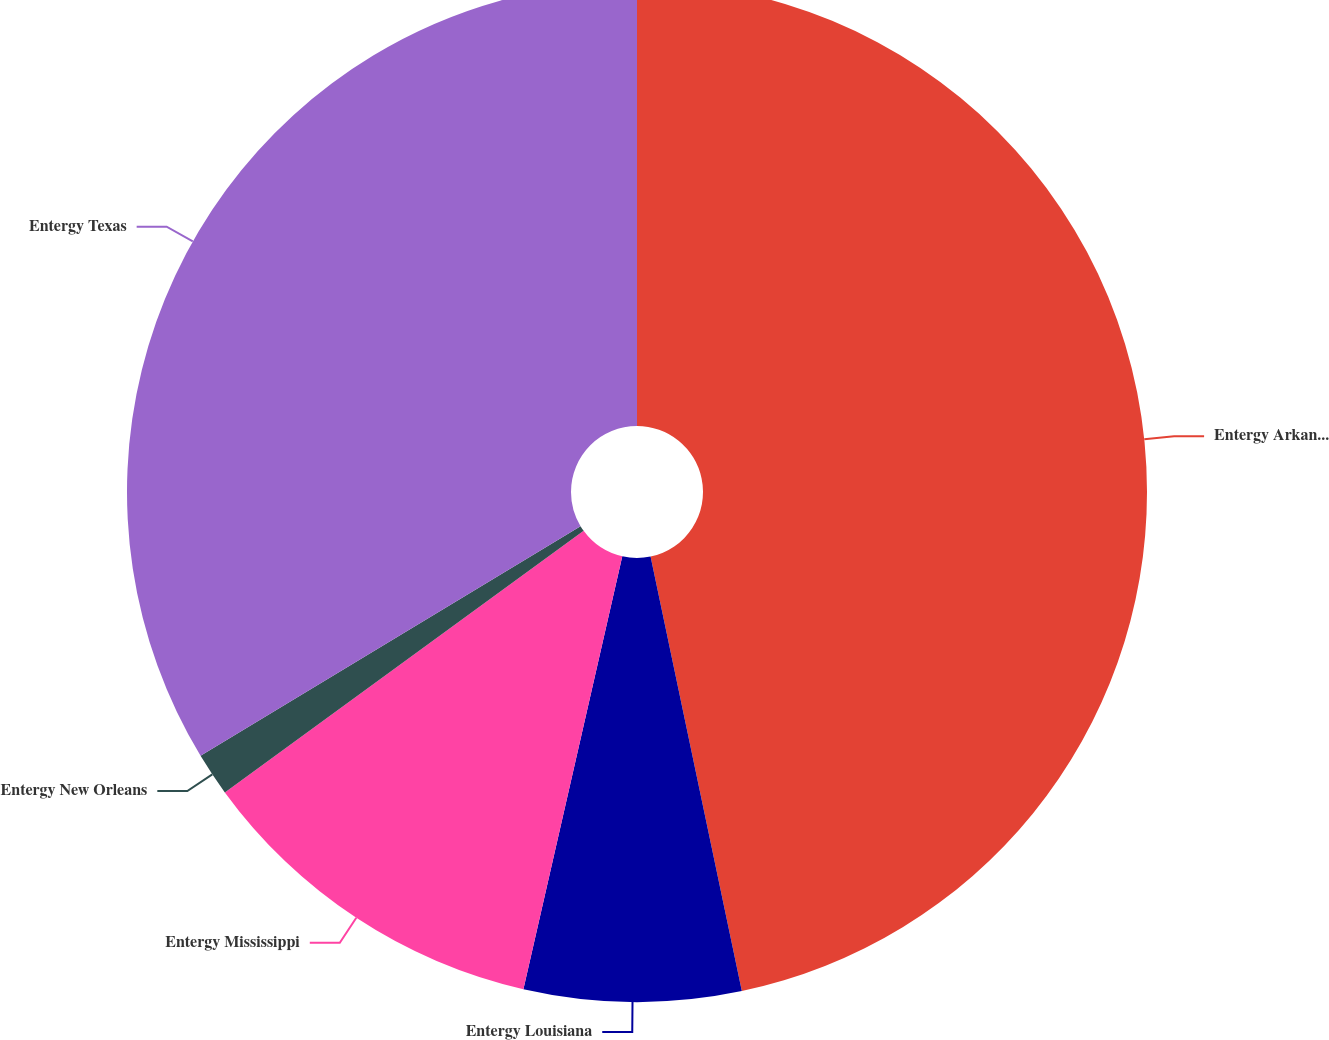<chart> <loc_0><loc_0><loc_500><loc_500><pie_chart><fcel>Entergy Arkansas<fcel>Entergy Louisiana<fcel>Entergy Mississippi<fcel>Entergy New Orleans<fcel>Entergy Texas<nl><fcel>46.7%<fcel>6.87%<fcel>11.4%<fcel>1.37%<fcel>33.65%<nl></chart> 